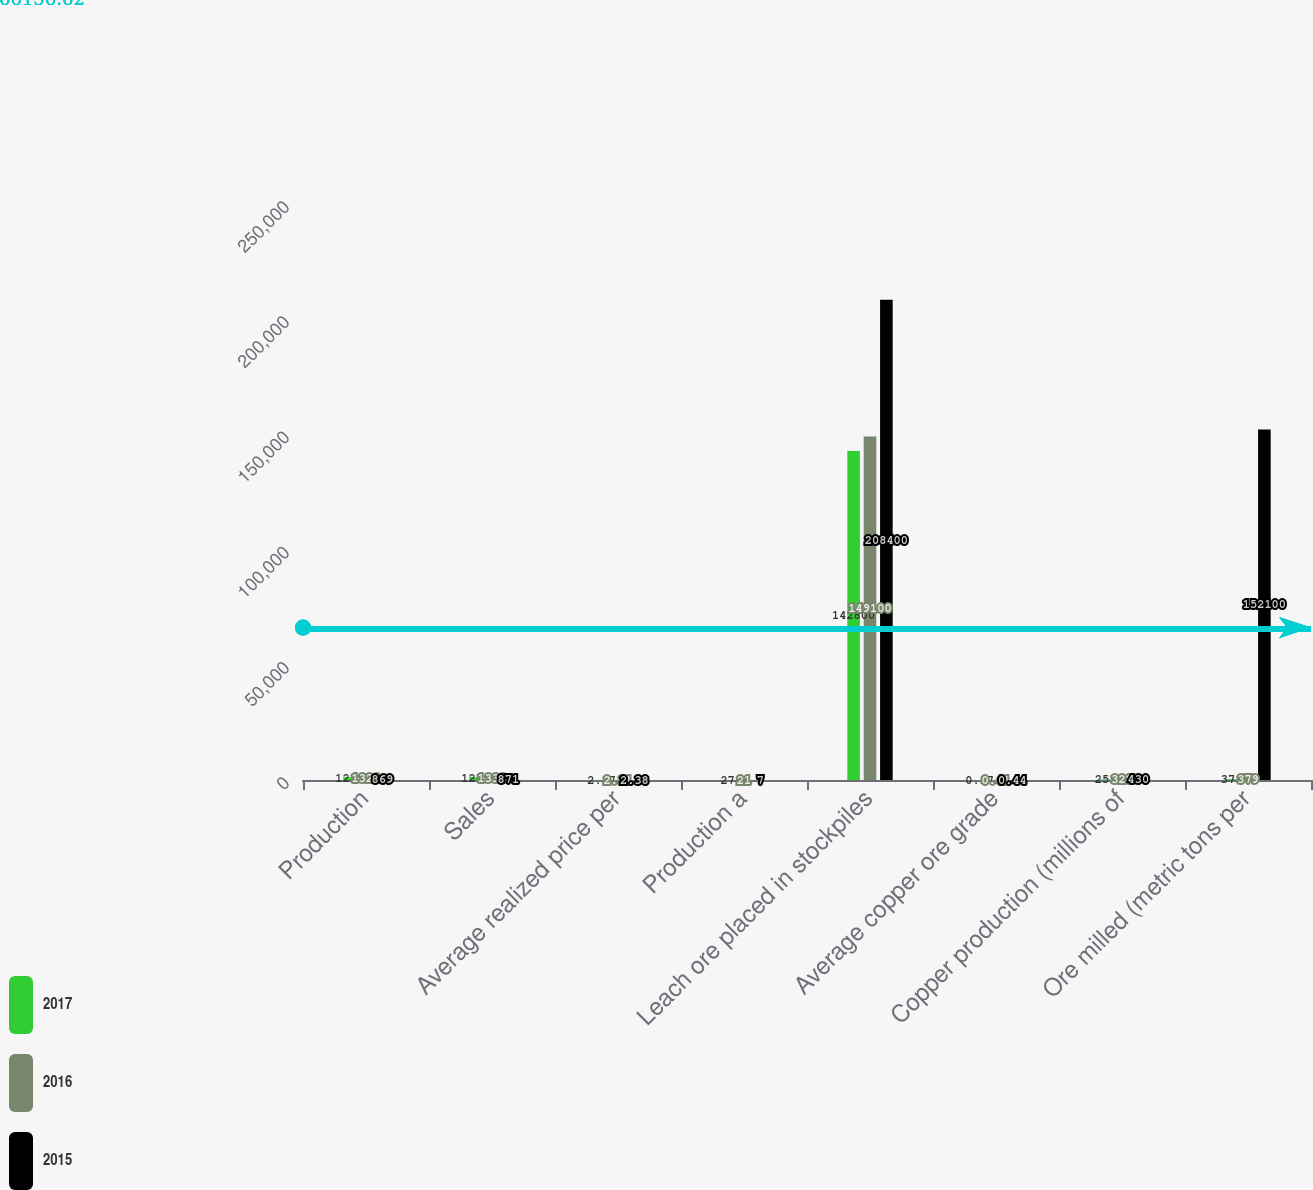<chart> <loc_0><loc_0><loc_500><loc_500><stacked_bar_chart><ecel><fcel>Production<fcel>Sales<fcel>Average realized price per<fcel>Production a<fcel>Leach ore placed in stockpiles<fcel>Average copper ore grade<fcel>Copper production (millions of<fcel>Ore milled (metric tons per<nl><fcel>2017<fcel>1235<fcel>1235<fcel>2.97<fcel>27<fcel>142800<fcel>0.37<fcel>255<fcel>379<nl><fcel>2016<fcel>1328<fcel>1332<fcel>2.31<fcel>21<fcel>149100<fcel>0.41<fcel>328<fcel>379<nl><fcel>2015<fcel>869<fcel>871<fcel>2.38<fcel>7<fcel>208400<fcel>0.44<fcel>430<fcel>152100<nl></chart> 